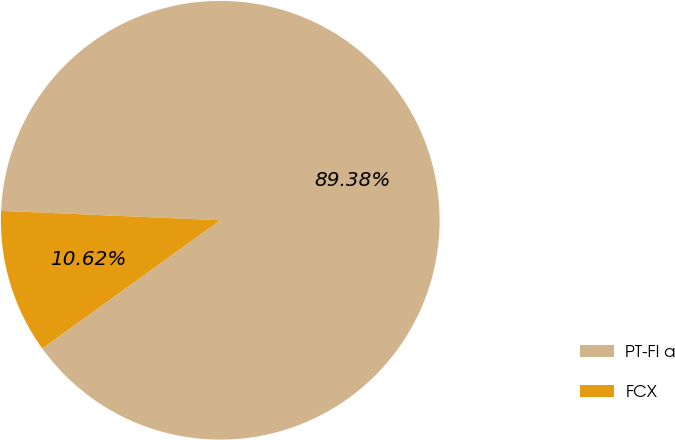Convert chart. <chart><loc_0><loc_0><loc_500><loc_500><pie_chart><fcel>PT-FI a<fcel>FCX<nl><fcel>89.38%<fcel>10.62%<nl></chart> 